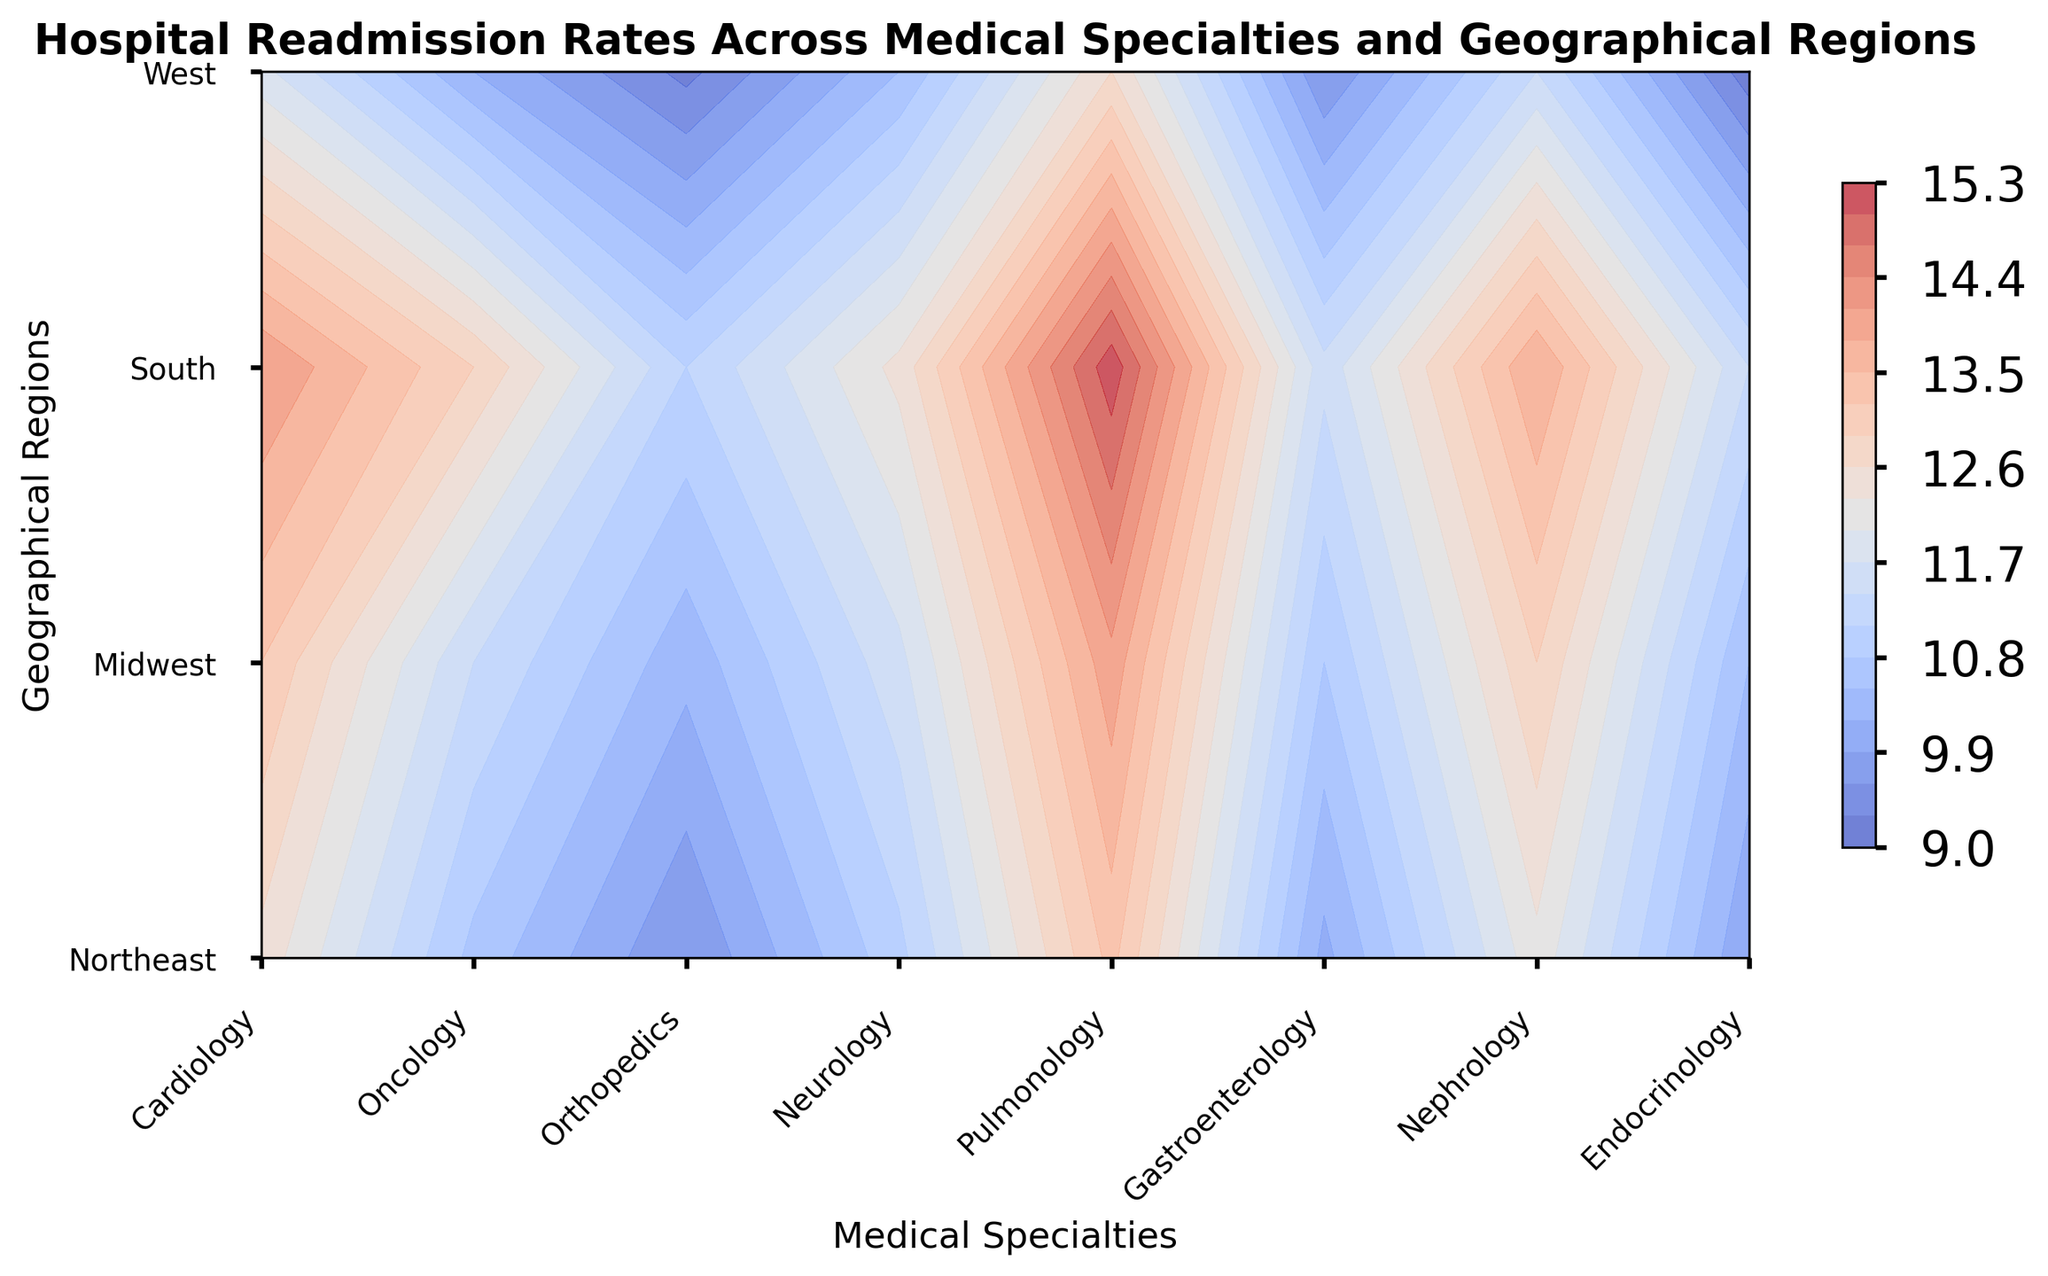Which medical specialty has the highest readmission rate in the South? First, identify the readmission rates for all medical specialties in the South. Then, compare these values to find the highest. Pulmonology has the highest rate with 15.2.
Answer: Pulmonology Which geographical region has the lowest readmission rate for Oncology? Examine the readmission rates for Oncology across all geographical regions and identify the lowest value. The West has the lowest rate at 10.2.
Answer: West What is the average readmission rate for Cardiology across all regions? Sum up the readmission rates for Cardiology across Northeast, Midwest, South, and West, and then divide by the number of regions. (12.5 + 13.2 + 14.1 + 11.8) / 4 = 12.9.
Answer: 12.9 Is the readmission rate for Endocrinology in the Northeast higher or lower than that of Orthopedics in the Midwest? Compare the readmission rate for Endocrinology in the Northeast (9.9) with Orthopedics in the Midwest (10.3). 9.9 is lower than 10.3.
Answer: Lower What is the difference between the highest and lowest readmission rates for Neurology? First, find the highest (South, 12.4) and lowest (West, 10.5) readmission rates for Neurology. Then, calculate the difference (12.4 - 10.5) = 1.9.
Answer: 1.9 Which medical specialty shows an overall trend of lower readmission rates in the West compared to the Northeast? Compare the readmission rates between the West and Northeast for each medical specialty and identify which show lower rates in the West. Endocrinology: (Northeast 9.9, West 9.1), Gastroenterology: (Northeast 10.1, West 9.6), Orthopedics: (Northeast 9.6, West 9.2), Oncology: (Northeast 10.7, West 10.2).
Answer: Endocrinology, Gastroenterology, Orthopedics, Oncology What is the color associated with the highest readmission rate on the contour plot? The contour plot uses a 'coolwarm' colormap. The highest readmission rates are represented with red tones.
Answer: Red What geographical region has the most consistent (least variation) readmission rates across all medical specialties? Evaluate each region's readmission rates across all medical specialties and calculate the variance to determine consistency. The Northeast has rates ranging from 9.6 to 13.3, the Midwest from 10.3 to 14.0, the South from 11.1 to 15.2, and the West from 9.2 to 12.6. Northeast has the smallest range of 3.7 (13.3 - 9.6).
Answer: Northeast Which medical specialty and region have almost equal readmission rates, visualized using similar contour shading? Compare the shading of different specialty and region combinations that share similar colors, indicating close readmission rates. Nephrology in the West (11.4) and Cardiology in the Midwest (13.2) have similar shading within close intervals, though the exact match would need contour line depth inspection. This step requires color-examination without precise numeric data manually adjusted via code.
Answer: Similar What is the average readmission rate for Pulmonology and Nephrology in the West? Sum up the readmission rates for Pulmonology in the West (12.6) and Nephrology in the West (11.4), then divide by 2. (12.6 + 11.4) / 2 = 12.0.
Answer: 12.0 